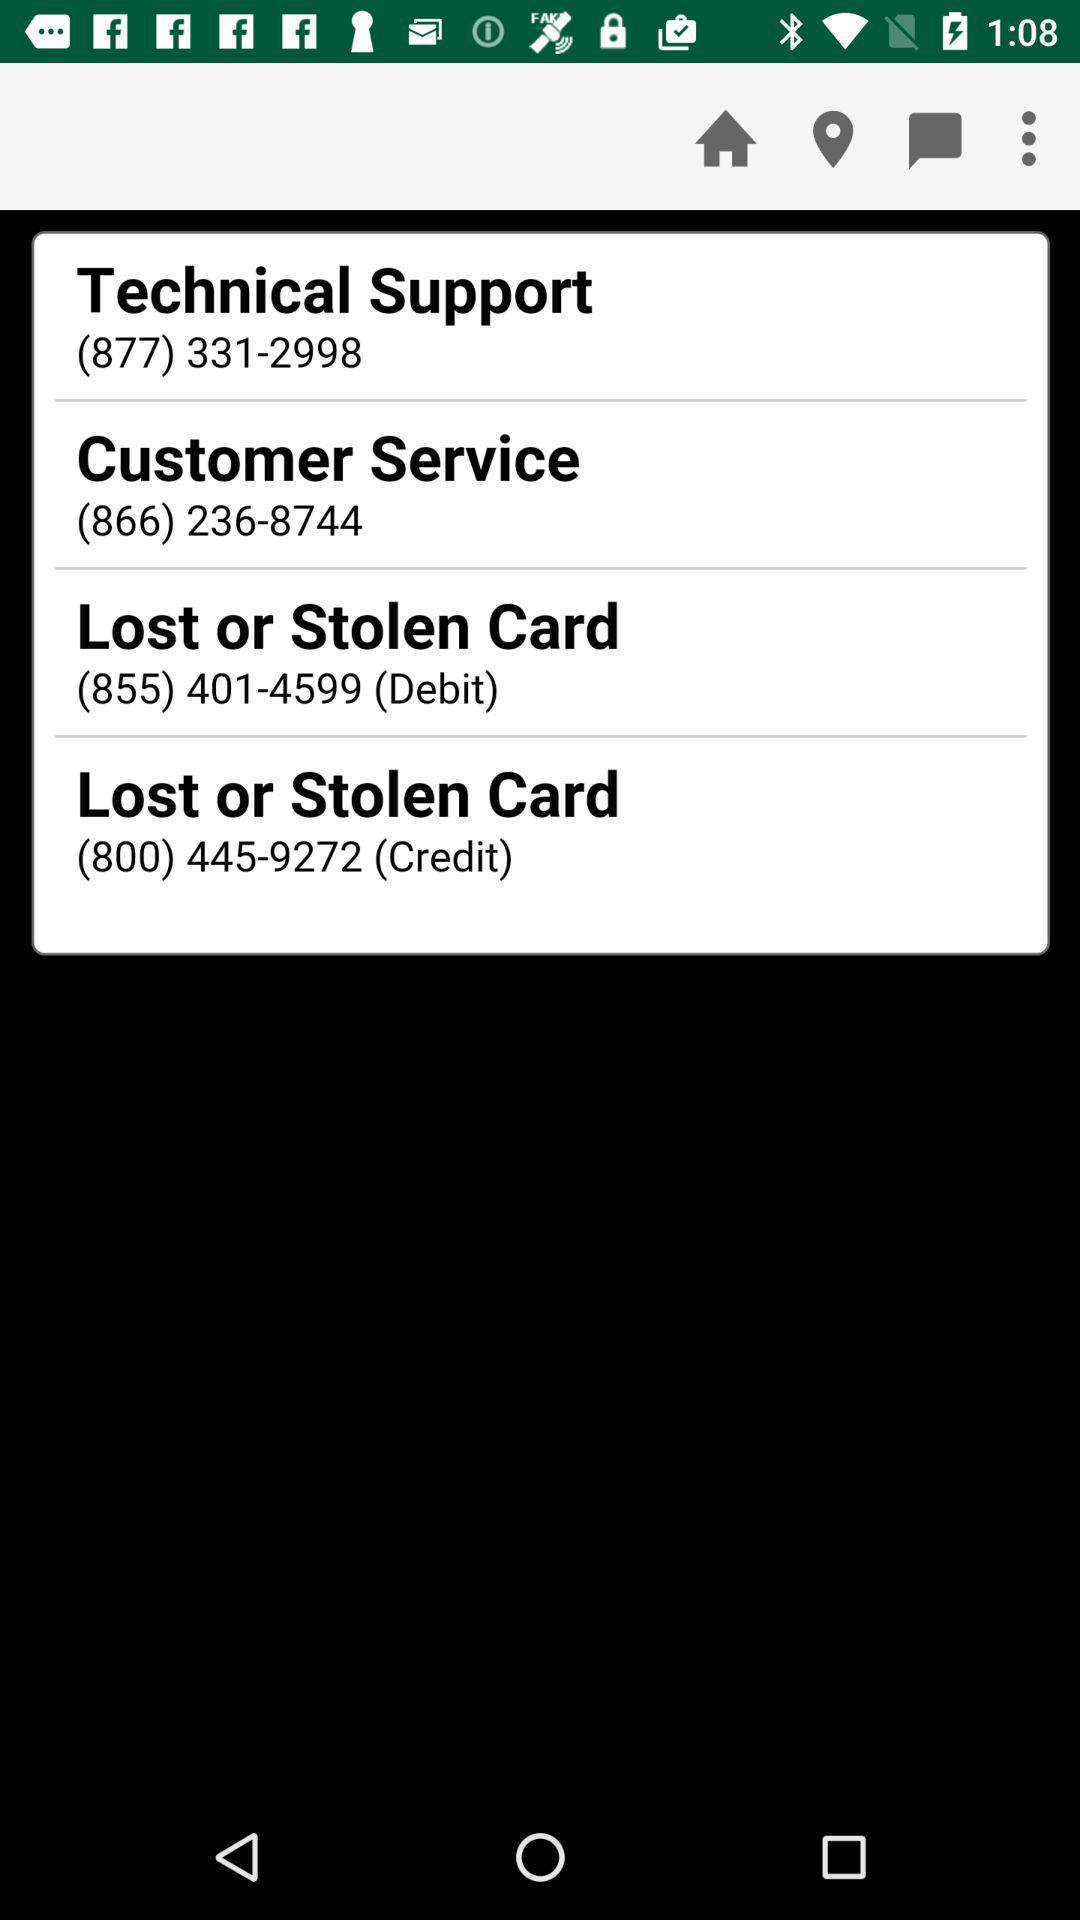What is the technical support contact number? The technical support contact number is (877) 331-2998. 